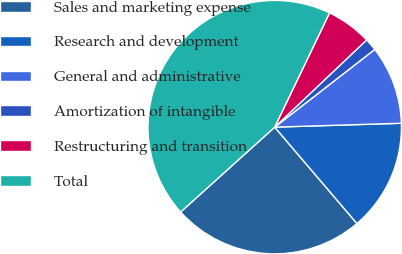Convert chart to OTSL. <chart><loc_0><loc_0><loc_500><loc_500><pie_chart><fcel>Sales and marketing expense<fcel>Research and development<fcel>General and administrative<fcel>Amortization of intangible<fcel>Restructuring and transition<fcel>Total<nl><fcel>24.56%<fcel>14.24%<fcel>10.02%<fcel>1.57%<fcel>5.8%<fcel>43.81%<nl></chart> 